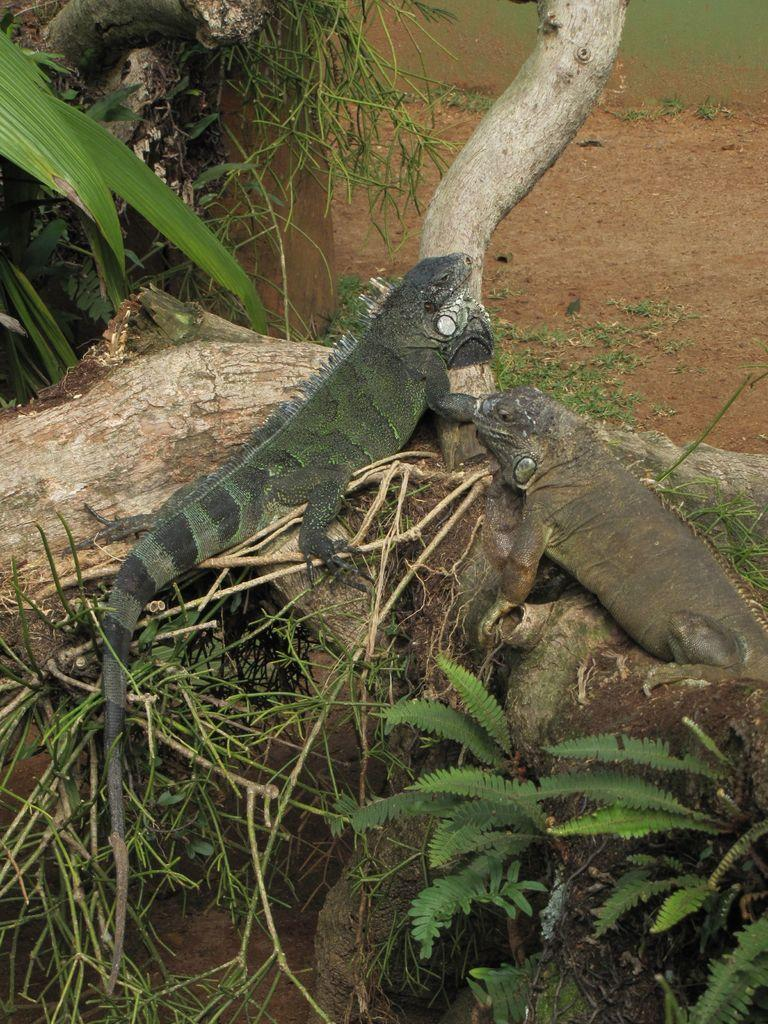What type of animals are on the tree in the image? There are two green Iguanas on the bark of the tree. What can be seen in the background of the image? Leaves are visible in the image. What material is present in the image? Glass is present in the image. What type of surface is visible in the image? Land is visible in the image. What is present at the bottom of the image? Some leaves and stems are present at the bottom of the image. What type of steel structure can be seen in the image? There is no steel structure present in the image; it features two green Iguanas on a tree with leaves and glass. 